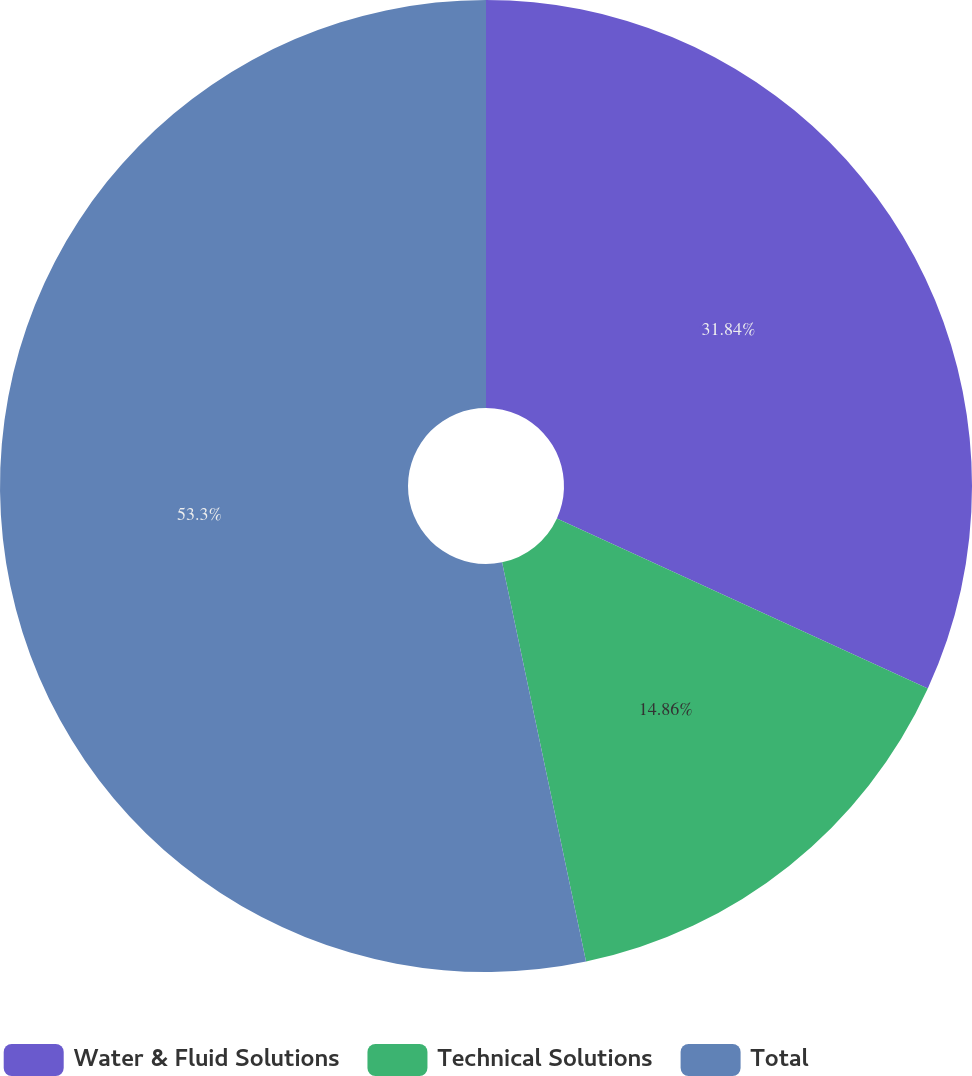<chart> <loc_0><loc_0><loc_500><loc_500><pie_chart><fcel>Water & Fluid Solutions<fcel>Technical Solutions<fcel>Total<nl><fcel>31.84%<fcel>14.86%<fcel>53.3%<nl></chart> 